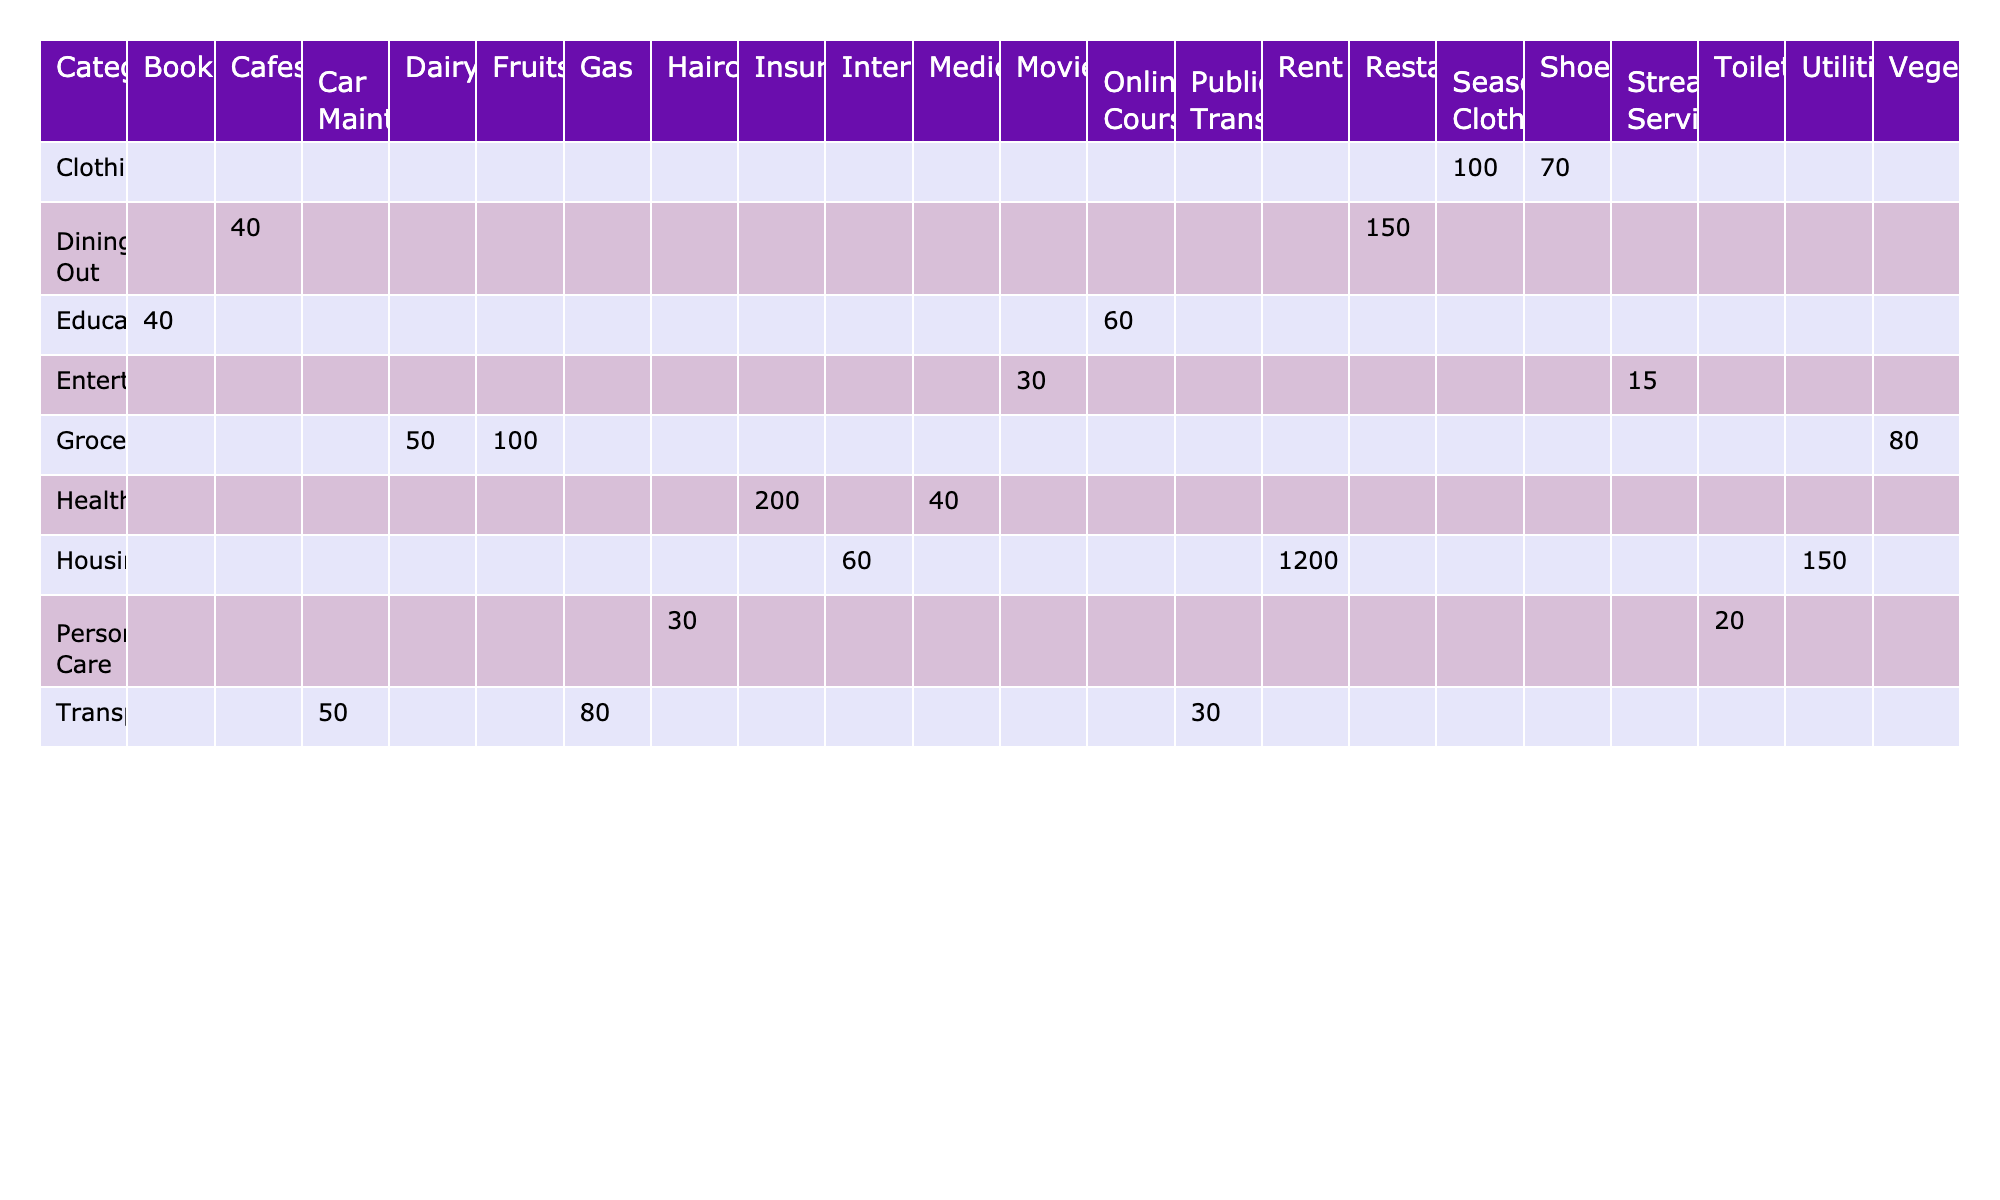What is the total amount spent on Groceries? The total amount for Groceries is calculated by adding up the values for Fruits, Vegetables, and Dairy: 100 + 80 + 50 = 230.
Answer: 230 How much is spent on Housing in total? To find the total spent on Housing, add the amounts for Rent, Utilities, and Internet: 1200 + 150 + 60 = 1410.
Answer: 1410 Is the amount spent on Transportation greater than the amount spent on Entertainment? The total for Transportation is 80 + 30 + 50 = 160, and for Entertainment, it is 15 + 30 = 45. Since 160 > 45, the statement is true.
Answer: Yes Which category has the highest individual expense? Looking through each category, Housing has the highest individual expense for Rent, which is 1200.
Answer: Housing What is the average expense for Dining Out? There are two subcategories in Dining Out: Restaurants (150) and Cafes (40). To calculate the average, sum them up: 150 + 40 = 190, then divide by 2, which equals 95.
Answer: 95 How much is spent on Healthcare compared to Clothing? For Healthcare, the total is 200 + 40 = 240, and for Clothing, it is 100 + 70 = 170. Since 240 > 170, more is spent on Healthcare.
Answer: Healthcare Which subcategory of Transportation is the least expensive? The amounts for Transportation subcategories are: Gas (80), Public Transport (30), and Car Maintenance (50). The least expensive is Public Transport with 30.
Answer: Public Transport What is the total amount spent on Personal Care? Add the amounts for Haircuts and Toiletries: 30 + 20 = 50.
Answer: 50 How much more is spent on Dining Out than on Personal Care? Dining Out total is 150 + 40 = 190, while Personal Care total is 30 + 20 = 50. The difference is 190 - 50 = 140.
Answer: 140 Calculate the total expenses for all categories combined. To find the total, sum all the amounts from each category: 1200 + 150 + 60 + 100 + 80 + 50 + 80 + 30 + 50 + 15 + 30 + 200 + 40 + 100 + 70 + 150 + 40 + 30 + 20 + 60 + 40 = 2385.
Answer: 2385 